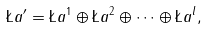Convert formula to latex. <formula><loc_0><loc_0><loc_500><loc_500>\L a ^ { \prime } = \L a ^ { 1 } \oplus \L a ^ { 2 } \oplus \cdots \oplus \L a ^ { l } ,</formula> 